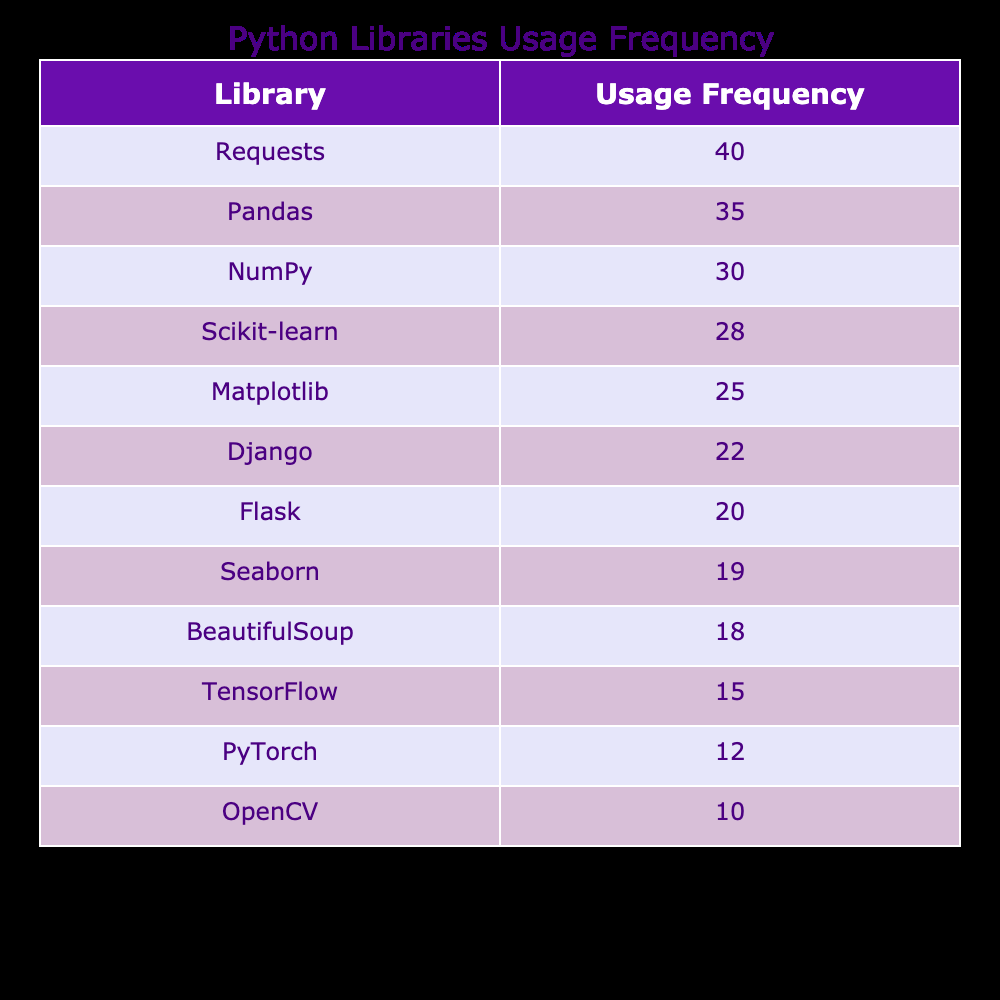What is the usage frequency of the Pandas library? According to the table, the Pandas library has a usage frequency of 35.
Answer: 35 Which library has the highest usage frequency? Looking at the table, the Requests library has the highest usage frequency at 40.
Answer: Requests What is the total usage frequency of the top three libraries? The top three libraries are Requests (40), Pandas (35), and NumPy (30). Summing these values gives 40 + 35 + 30 = 105.
Answer: 105 Is Matplotlib's usage frequency greater than that of TensorFlow? The usage frequency of Matplotlib is 25, while TensorFlow's is 15. Since 25 is greater than 15, the answer is yes.
Answer: Yes What is the median usage frequency of all libraries listed? First, we need to list the usage frequencies in order: 10, 12, 15, 18, 19, 20, 22, 25, 28, 30, 35, 40. There are 12 values, so the median will be the average of the 6th and 7th values, which are 20 and 22. The median is (20 + 22) / 2 = 21.
Answer: 21 How many libraries have a usage frequency below 20? In the table, the libraries with a usage frequency below 20 are OpenCV (10), PyTorch (12), BeautifulSoup (18), which totals to 3 libraries.
Answer: 3 Which library has a frequency that is 5 less than that of Scikit-learn? Scikit-learn has a usage frequency of 28. If we subtract 5, we get 28 - 5 = 23. However, there is no library with this exact frequency.
Answer: None What is the combined usage frequency of Flask and Django? Flask has a usage frequency of 20 and Django has a frequency of 22. Summing these gives 20 + 22 = 42.
Answer: 42 Is the usage frequency of PyTorch less than that of Seaborn? PyTorch has a usage frequency of 12, while Seaborn has 19. Since 12 is less than 19, the answer is yes.
Answer: Yes 